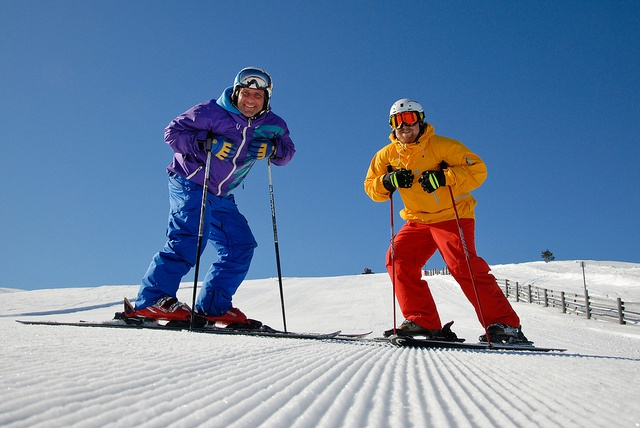Describe the objects in this image and their specific colors. I can see people in gray, navy, black, darkgray, and darkblue tones, people in gray, maroon, and red tones, skis in gray, black, lightgray, and darkgray tones, and skis in gray, black, and darkgray tones in this image. 